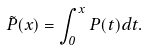Convert formula to latex. <formula><loc_0><loc_0><loc_500><loc_500>\tilde { P } ( x ) = \int _ { 0 } ^ { x } P ( t ) d t .</formula> 